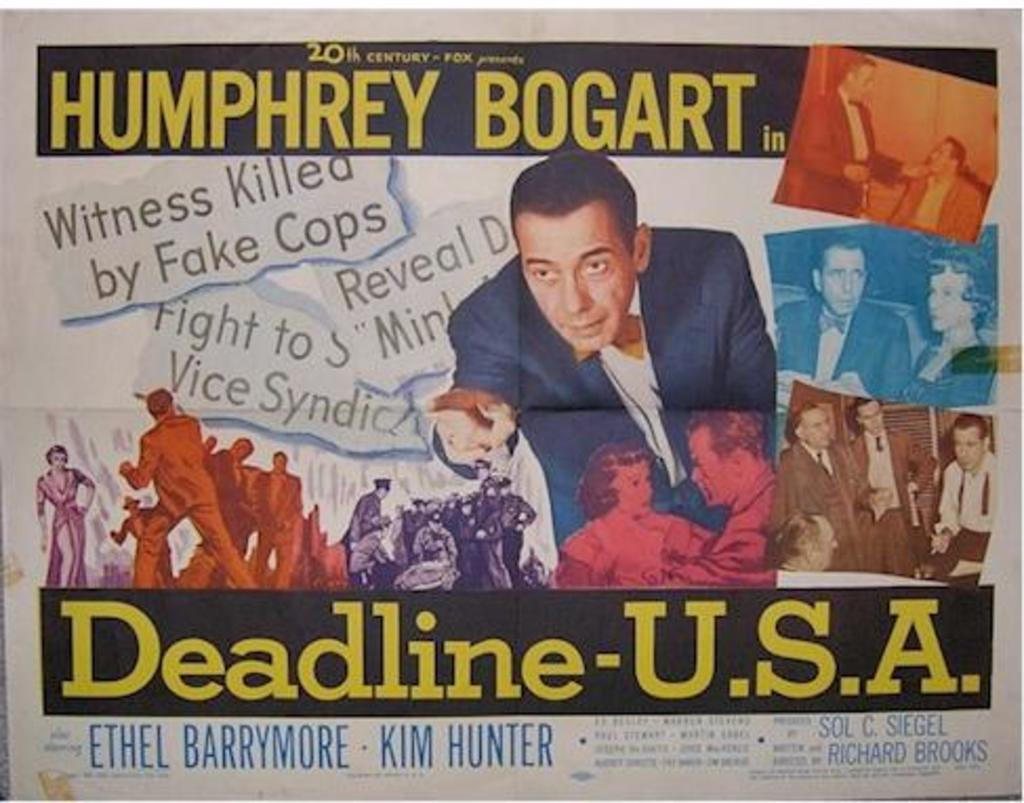Provide a one-sentence caption for the provided image. a news paper clipping with humphrey bogart in deadline usa. 